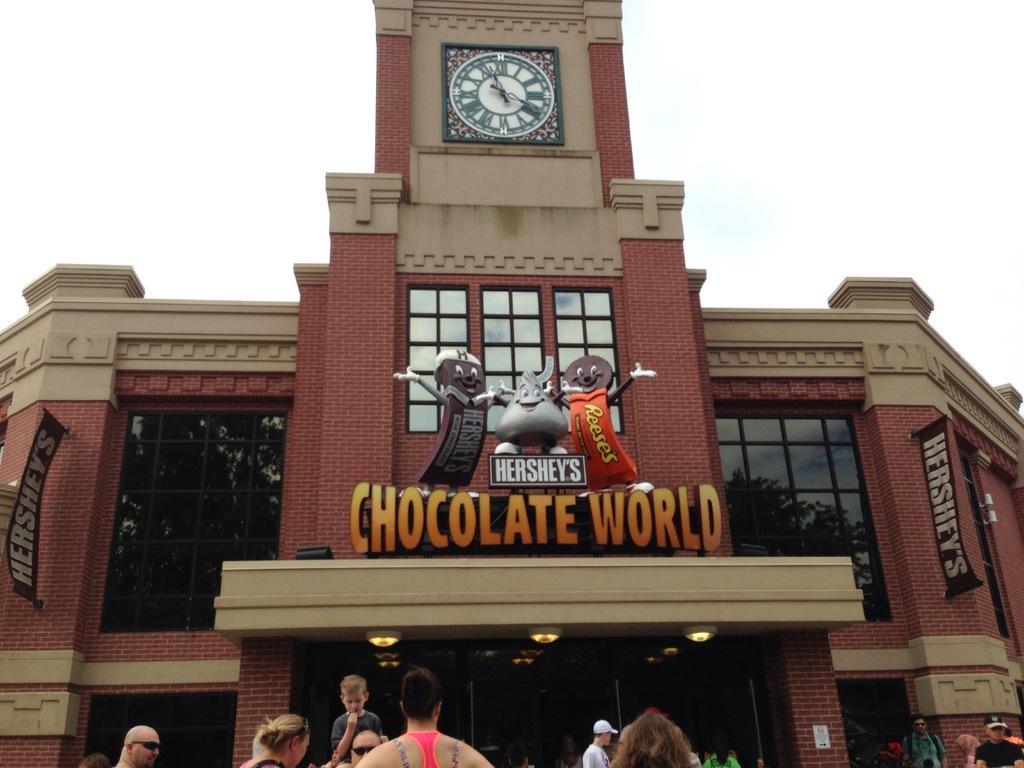How would you summarize this image in a sentence or two? It is a building there are chocolate toys on it. At the top it's a clock. 